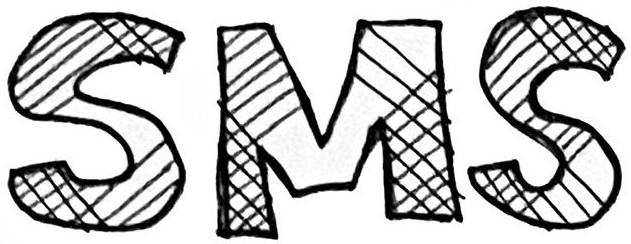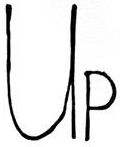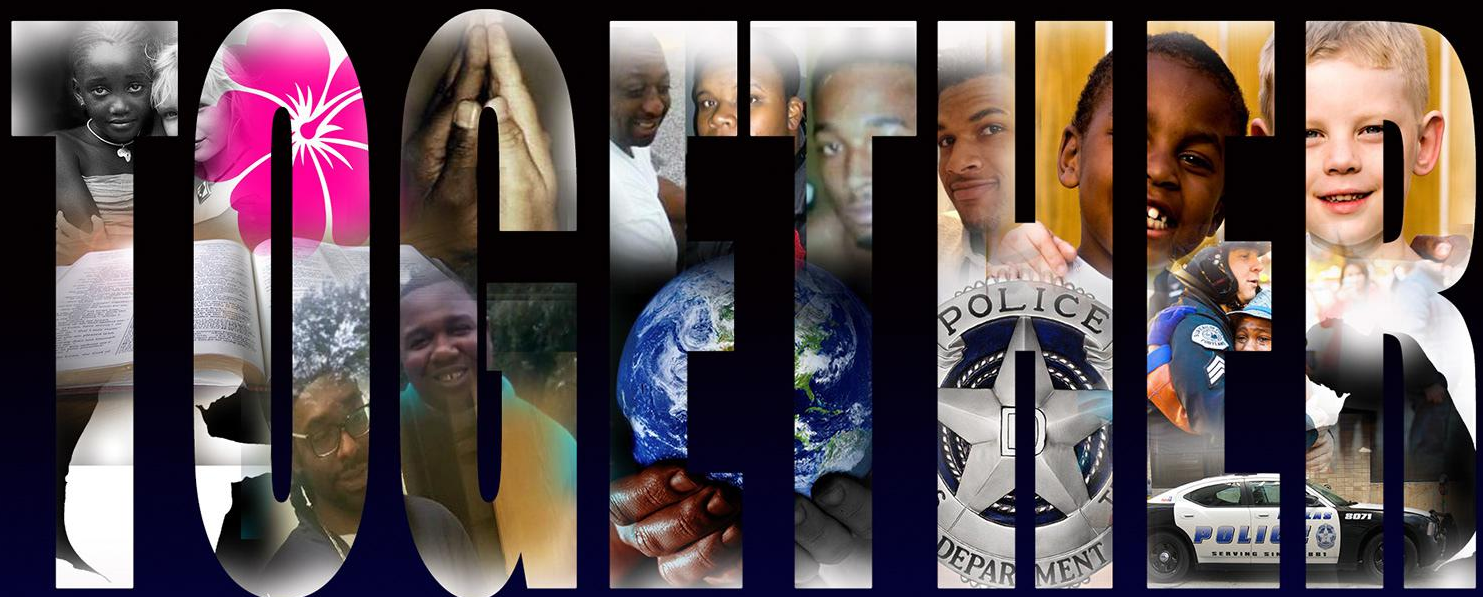What words are shown in these images in order, separated by a semicolon? SMS; UP; TOGETHER 